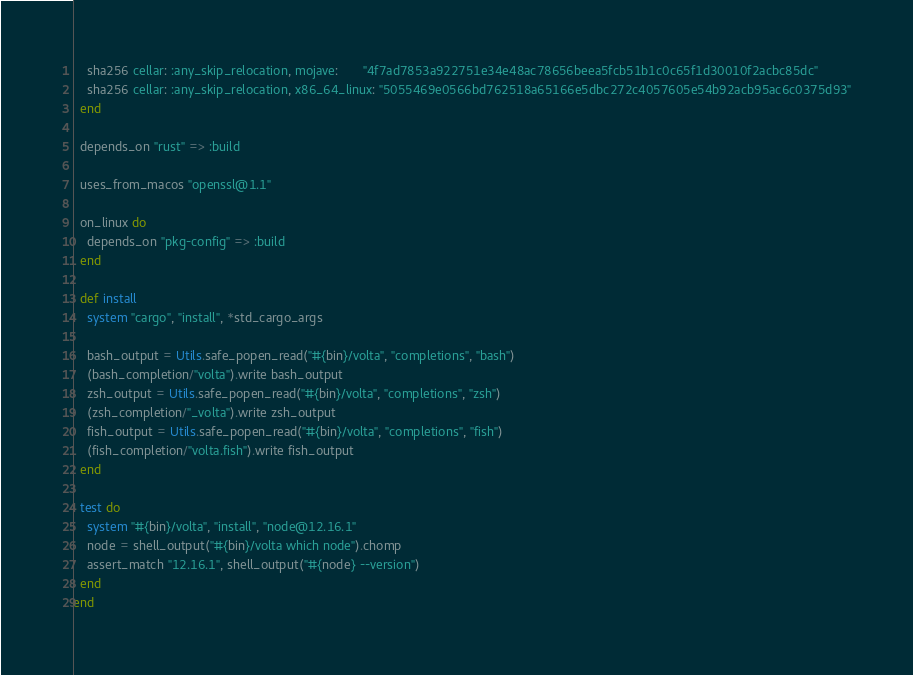Convert code to text. <code><loc_0><loc_0><loc_500><loc_500><_Ruby_>    sha256 cellar: :any_skip_relocation, mojave:       "4f7ad7853a922751e34e48ac78656beea5fcb51b1c0c65f1d30010f2acbc85dc"
    sha256 cellar: :any_skip_relocation, x86_64_linux: "5055469e0566bd762518a65166e5dbc272c4057605e54b92acb95ac6c0375d93"
  end

  depends_on "rust" => :build

  uses_from_macos "openssl@1.1"

  on_linux do
    depends_on "pkg-config" => :build
  end

  def install
    system "cargo", "install", *std_cargo_args

    bash_output = Utils.safe_popen_read("#{bin}/volta", "completions", "bash")
    (bash_completion/"volta").write bash_output
    zsh_output = Utils.safe_popen_read("#{bin}/volta", "completions", "zsh")
    (zsh_completion/"_volta").write zsh_output
    fish_output = Utils.safe_popen_read("#{bin}/volta", "completions", "fish")
    (fish_completion/"volta.fish").write fish_output
  end

  test do
    system "#{bin}/volta", "install", "node@12.16.1"
    node = shell_output("#{bin}/volta which node").chomp
    assert_match "12.16.1", shell_output("#{node} --version")
  end
end
</code> 